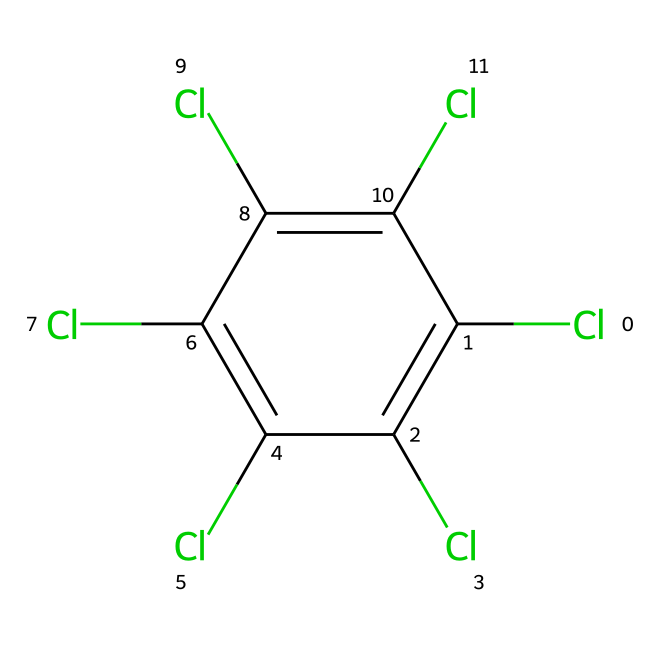What is the chemical name of this compound? The provided SMILES notation represents a chemical structure that corresponds to a compound known as tetrachlorobenzene. This is determined by analyzing the arrangement of chlorine atoms and the carbon atoms in the cyclic structure, indicating it has multiple chlorine substituents on a benzene ring.
Answer: tetrachlorobenzene How many chlorine atoms are present in this molecule? To determine the number of chlorine atoms, we can count the instances of 'Cl' in the SMILES representation. The structure shows five chlorine atoms attached to the carbons of the benzene ring.
Answer: five What type of chemical compound is this? Given the structure and chlorine content, this compound is classified as a halogenated aromatic hydrocarbon. The presence of multiple chlorine substituents on an aromatic ring characterizes it as such.
Answer: halogenated aromatic hydrocarbon Which molecular feature contributes to its hazardous nature? The presence of multiple chlorine atoms significantly contributes to its hazardous nature by increasing its toxicity and persistence in the environment, as chlorine is known for its harmful effects and bioaccumulation potential.
Answer: chlorine atoms What is the potential environmental concern associated with this chemical? Being a halogenated compound, tetrachlorobenzene poses risks of soil and water contamination, leading to ecological disturbances. Its toxicity can affect aquatic life and disrupt ecosystem functions.
Answer: contamination 